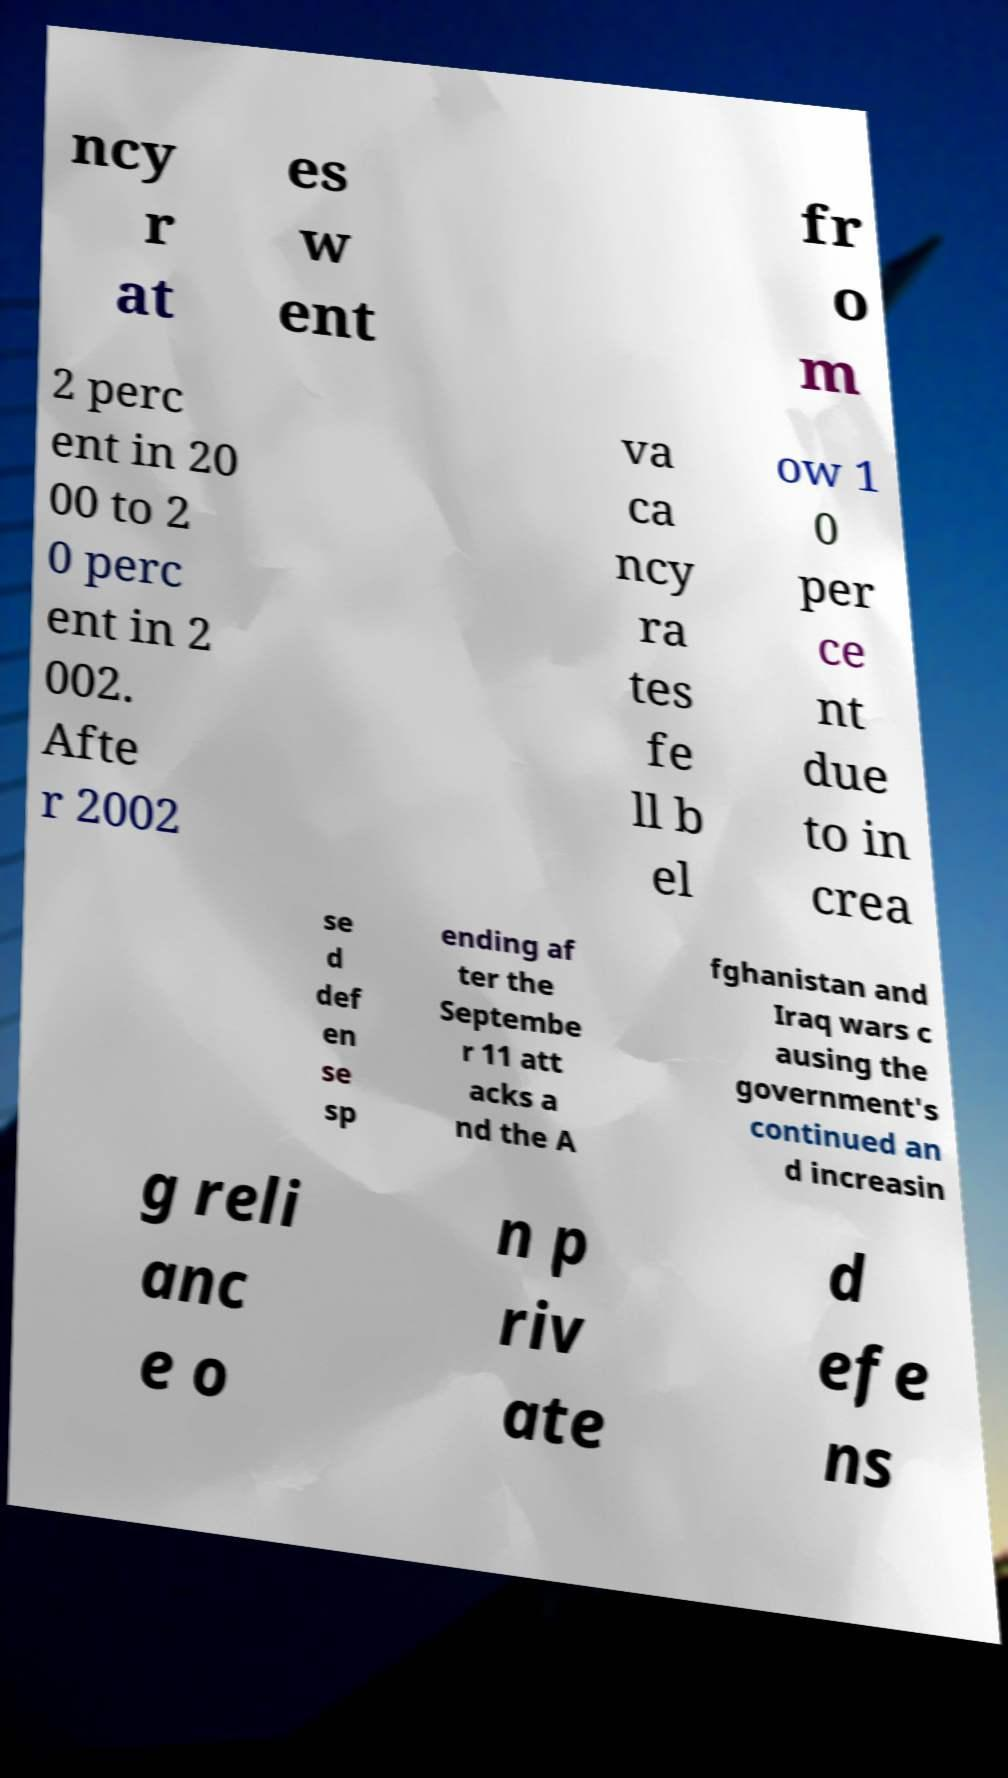Please identify and transcribe the text found in this image. ncy r at es w ent fr o m 2 perc ent in 20 00 to 2 0 perc ent in 2 002. Afte r 2002 va ca ncy ra tes fe ll b el ow 1 0 per ce nt due to in crea se d def en se sp ending af ter the Septembe r 11 att acks a nd the A fghanistan and Iraq wars c ausing the government's continued an d increasin g reli anc e o n p riv ate d efe ns 